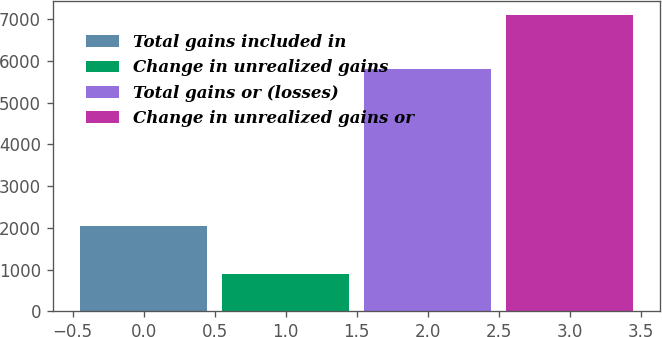<chart> <loc_0><loc_0><loc_500><loc_500><bar_chart><fcel>Total gains included in<fcel>Change in unrealized gains<fcel>Total gains or (losses)<fcel>Change in unrealized gains or<nl><fcel>2056<fcel>897<fcel>5803<fcel>7096<nl></chart> 